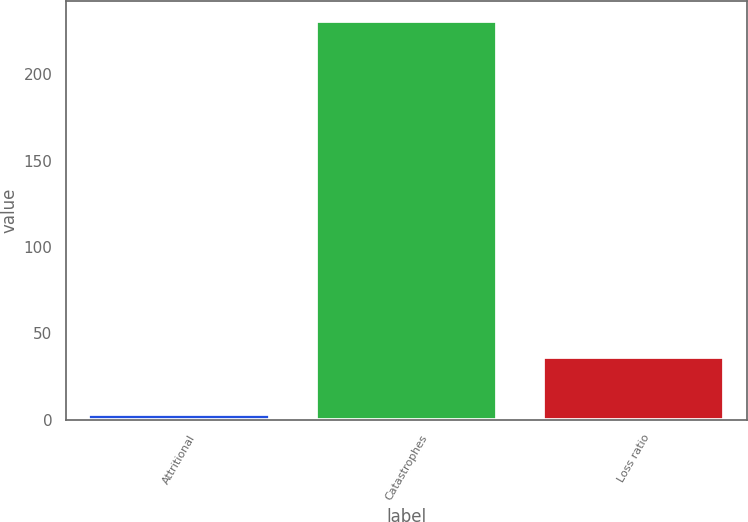<chart> <loc_0><loc_0><loc_500><loc_500><bar_chart><fcel>Attritional<fcel>Catastrophes<fcel>Loss ratio<nl><fcel>3.2<fcel>231.1<fcel>36.3<nl></chart> 